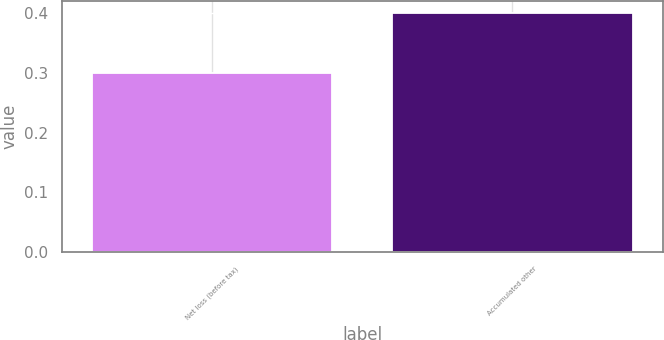Convert chart to OTSL. <chart><loc_0><loc_0><loc_500><loc_500><bar_chart><fcel>Net loss (before tax)<fcel>Accumulated other<nl><fcel>0.3<fcel>0.4<nl></chart> 